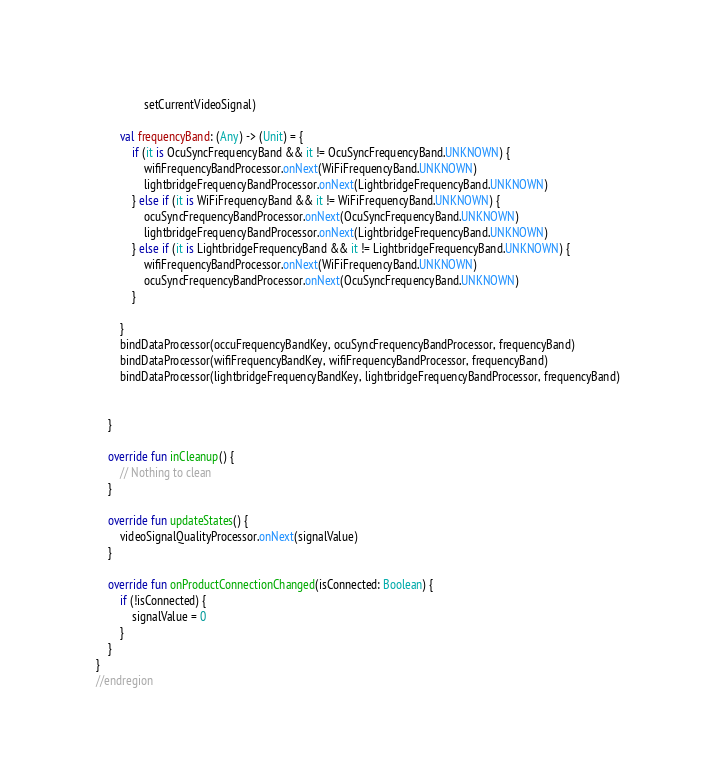<code> <loc_0><loc_0><loc_500><loc_500><_Kotlin_>                setCurrentVideoSignal)

        val frequencyBand: (Any) -> (Unit) = {
            if (it is OcuSyncFrequencyBand && it != OcuSyncFrequencyBand.UNKNOWN) {
                wifiFrequencyBandProcessor.onNext(WiFiFrequencyBand.UNKNOWN)
                lightbridgeFrequencyBandProcessor.onNext(LightbridgeFrequencyBand.UNKNOWN)
            } else if (it is WiFiFrequencyBand && it != WiFiFrequencyBand.UNKNOWN) {
                ocuSyncFrequencyBandProcessor.onNext(OcuSyncFrequencyBand.UNKNOWN)
                lightbridgeFrequencyBandProcessor.onNext(LightbridgeFrequencyBand.UNKNOWN)
            } else if (it is LightbridgeFrequencyBand && it != LightbridgeFrequencyBand.UNKNOWN) {
                wifiFrequencyBandProcessor.onNext(WiFiFrequencyBand.UNKNOWN)
                ocuSyncFrequencyBandProcessor.onNext(OcuSyncFrequencyBand.UNKNOWN)
            }

        }
        bindDataProcessor(occuFrequencyBandKey, ocuSyncFrequencyBandProcessor, frequencyBand)
        bindDataProcessor(wifiFrequencyBandKey, wifiFrequencyBandProcessor, frequencyBand)
        bindDataProcessor(lightbridgeFrequencyBandKey, lightbridgeFrequencyBandProcessor, frequencyBand)


    }

    override fun inCleanup() {
        // Nothing to clean
    }

    override fun updateStates() {
        videoSignalQualityProcessor.onNext(signalValue)
    }

    override fun onProductConnectionChanged(isConnected: Boolean) {
        if (!isConnected) {
            signalValue = 0
        }
    }
}
//endregion
</code> 